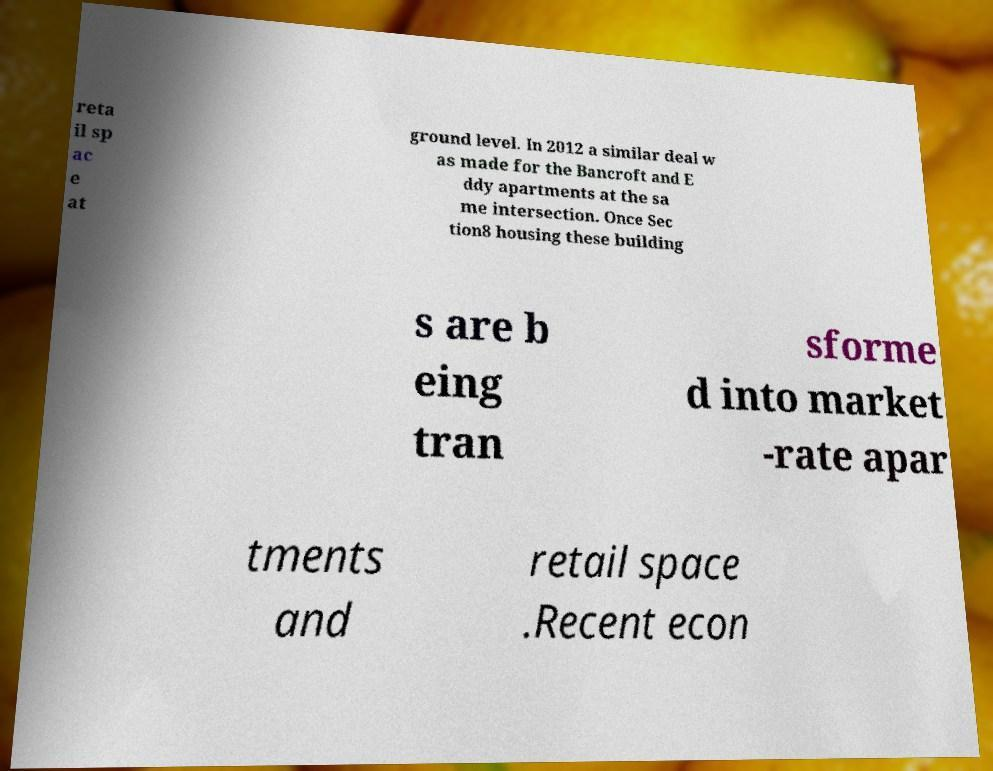Could you extract and type out the text from this image? reta il sp ac e at ground level. In 2012 a similar deal w as made for the Bancroft and E ddy apartments at the sa me intersection. Once Sec tion8 housing these building s are b eing tran sforme d into market -rate apar tments and retail space .Recent econ 